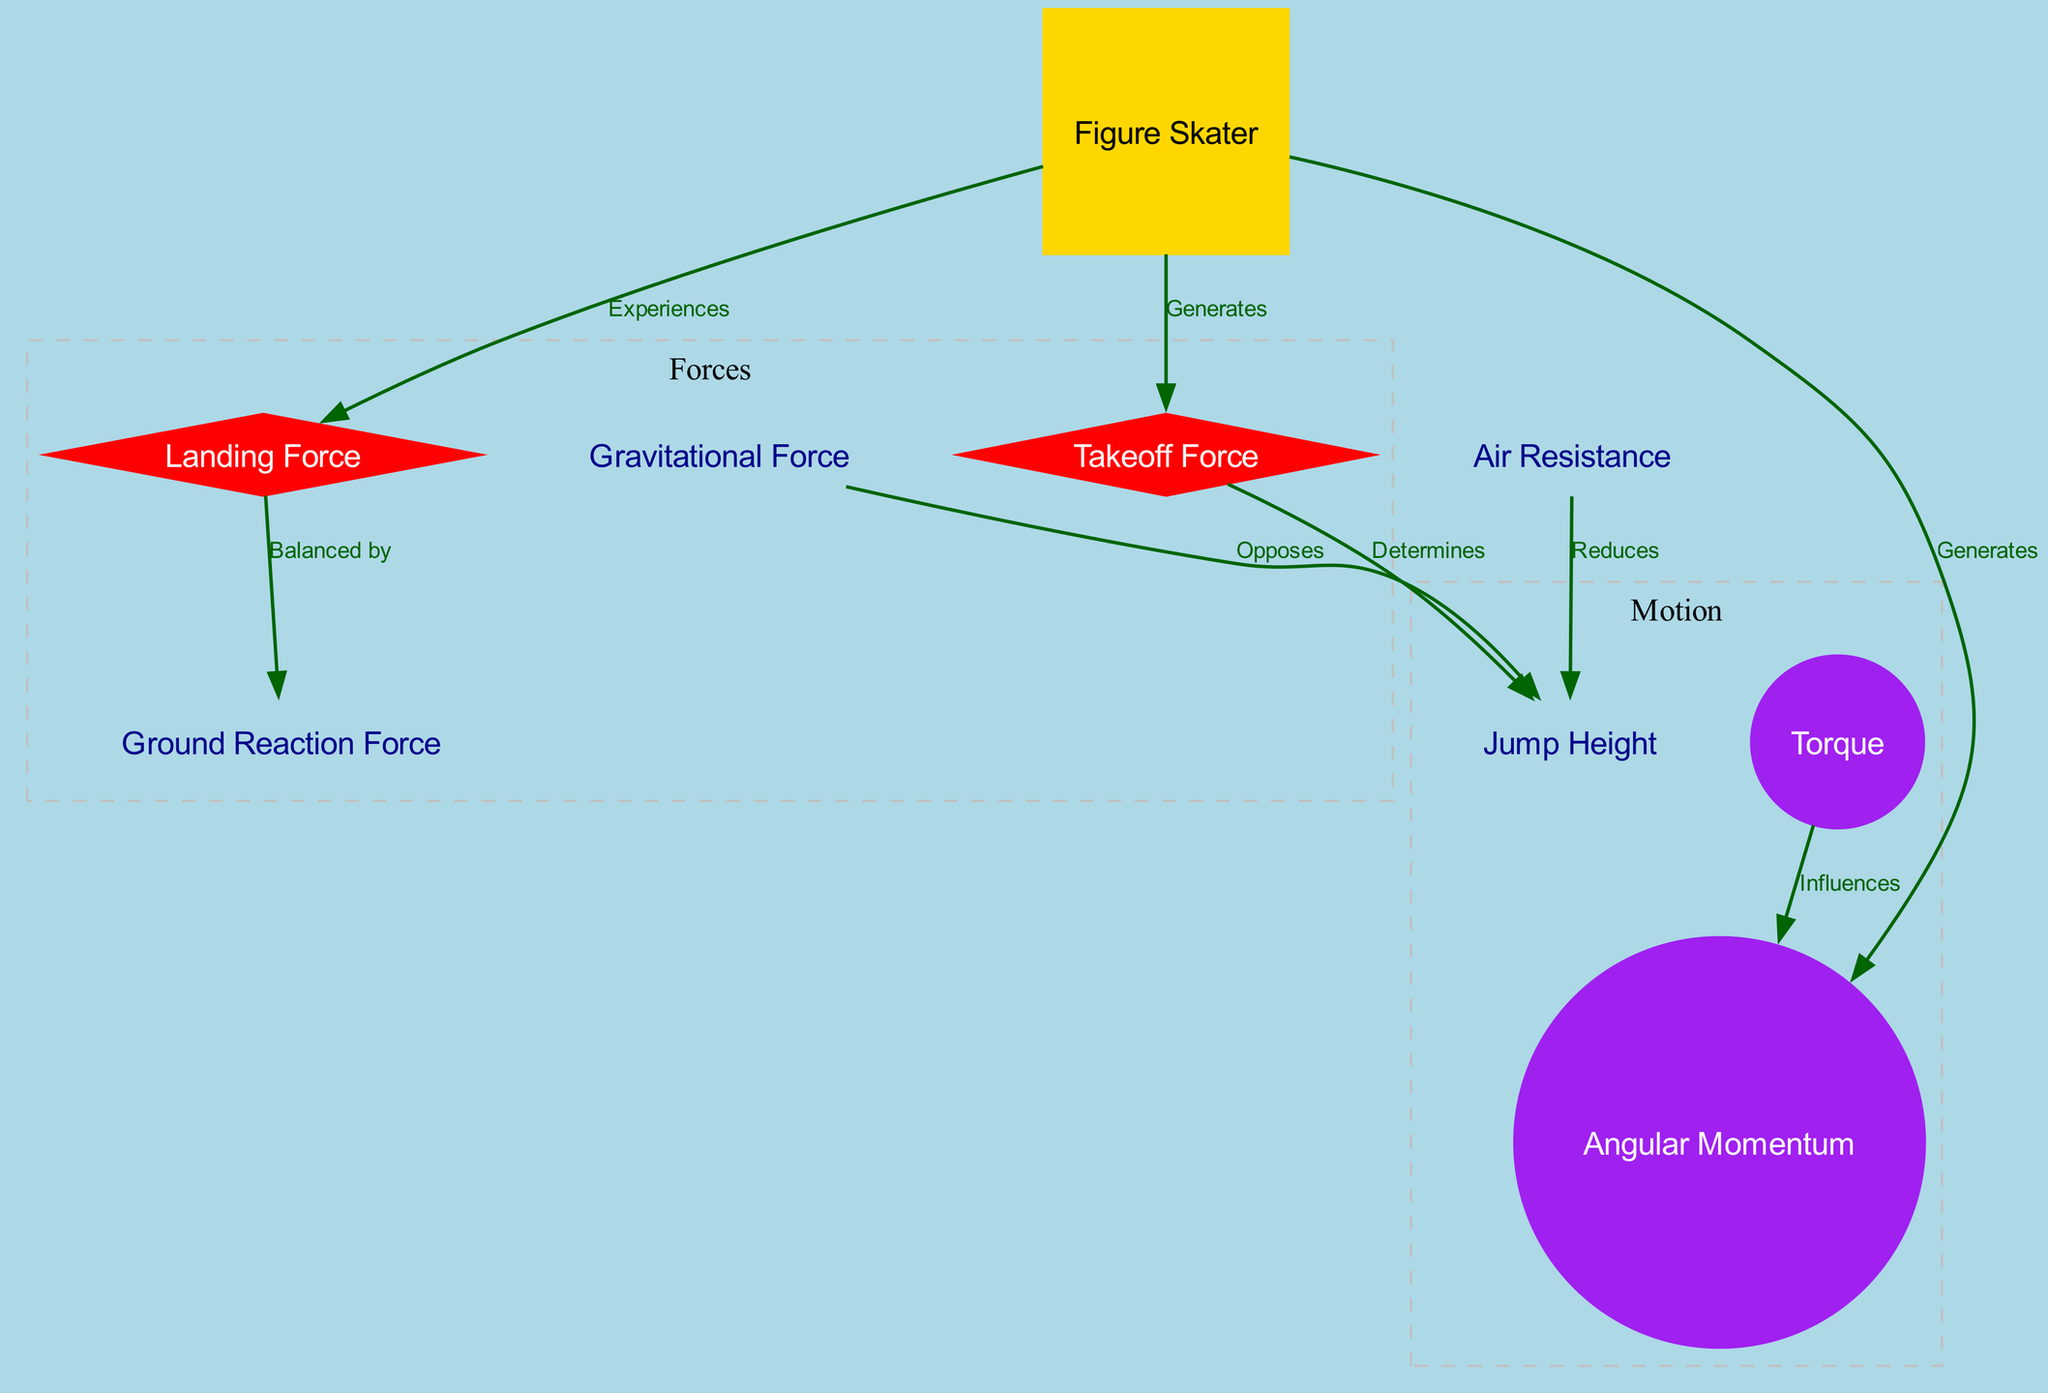What is the main entity depicted in the diagram? The main entity in the diagram is the "Figure Skater," as indicated by the node labeled "Figure Skater," which is a central component that influences the other elements in the diagram.
Answer: Figure Skater How many forces are depicted in the diagram? The diagram includes four forces: "Takeoff Force," "Gravitational Force," "Air Resistance," and "Landing Force." This is counted by identifying the nodes categorized under forces within the diagram.
Answer: 4 What does the takeoff force determine? The "Takeoff Force" determines the "Jump Height," as represented by the directional edge labeled "Determines" pointing from "Takeoff Force" to "Jump Height."
Answer: Jump Height Which force is opposed by gravitational force? The "Jump Height" is opposed by "Gravitational Force," as shown by the edge labeled "Opposes" that connects these two nodes in the diagram.
Answer: Jump Height How does torque influence angular momentum? "Torque" influences "Angular Momentum," as indicated by the connection labeled "Influences" between those two nodes, illustrating the relationship where torque affects the rotational aspect of the jump.
Answer: Angular Momentum What are the two forces that the skater experiences? The skater experiences both the "Takeoff Force" and the "Landing Force," as indicated by the edges connecting "Figure Skater" to both forces, showing direct involvement.
Answer: Takeoff Force, Landing Force What counteracts the landing force? The "Ground Reaction Force" balances the "Landing Force," as indicated by the edge labeled "Balanced by" connecting "Landing Force" to "Ground Reaction Force."
Answer: Ground Reaction Force Which force reduces the jump height? The "Air Resistance" reduces the "Jump Height," as depicted by the edge labeled "Reduces" that connects these two nodes, demonstrating the opposing influence of air on the jump.
Answer: Air Resistance How does angular momentum relate to the skater? The "Figure Skater" generates "Angular Momentum," as specified by the connection labeled "Generates" from the "Figure Skater" to the "Angular Momentum," indicating that the skater's movement creates this rotational energy.
Answer: Angular Momentum 